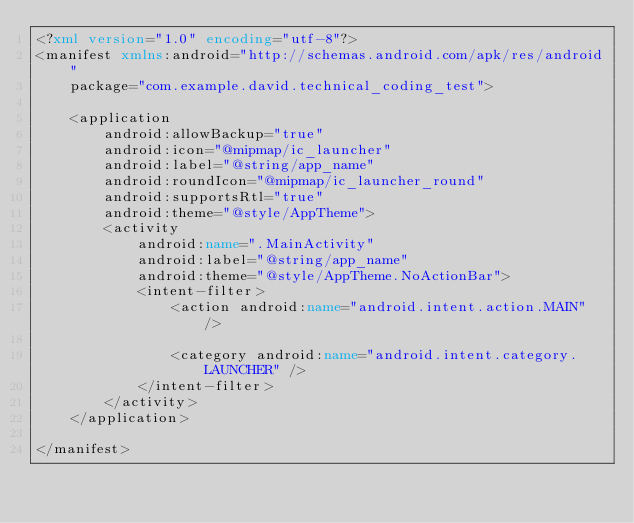<code> <loc_0><loc_0><loc_500><loc_500><_XML_><?xml version="1.0" encoding="utf-8"?>
<manifest xmlns:android="http://schemas.android.com/apk/res/android"
    package="com.example.david.technical_coding_test">

    <application
        android:allowBackup="true"
        android:icon="@mipmap/ic_launcher"
        android:label="@string/app_name"
        android:roundIcon="@mipmap/ic_launcher_round"
        android:supportsRtl="true"
        android:theme="@style/AppTheme">
        <activity
            android:name=".MainActivity"
            android:label="@string/app_name"
            android:theme="@style/AppTheme.NoActionBar">
            <intent-filter>
                <action android:name="android.intent.action.MAIN" />

                <category android:name="android.intent.category.LAUNCHER" />
            </intent-filter>
        </activity>
    </application>

</manifest></code> 